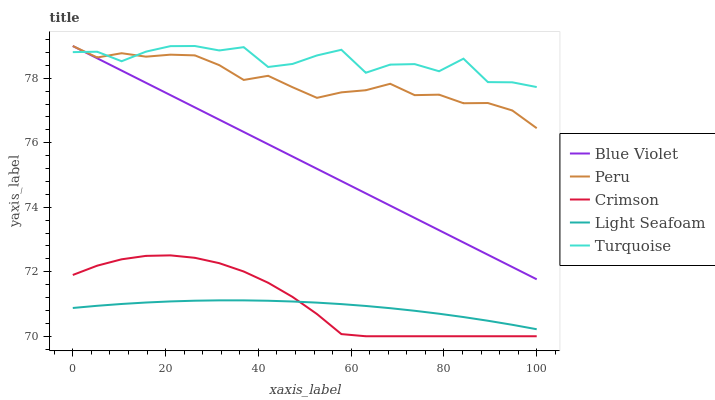Does Light Seafoam have the minimum area under the curve?
Answer yes or no. Yes. Does Turquoise have the maximum area under the curve?
Answer yes or no. Yes. Does Turquoise have the minimum area under the curve?
Answer yes or no. No. Does Light Seafoam have the maximum area under the curve?
Answer yes or no. No. Is Blue Violet the smoothest?
Answer yes or no. Yes. Is Turquoise the roughest?
Answer yes or no. Yes. Is Light Seafoam the smoothest?
Answer yes or no. No. Is Light Seafoam the roughest?
Answer yes or no. No. Does Crimson have the lowest value?
Answer yes or no. Yes. Does Light Seafoam have the lowest value?
Answer yes or no. No. Does Blue Violet have the highest value?
Answer yes or no. Yes. Does Light Seafoam have the highest value?
Answer yes or no. No. Is Crimson less than Blue Violet?
Answer yes or no. Yes. Is Blue Violet greater than Light Seafoam?
Answer yes or no. Yes. Does Peru intersect Blue Violet?
Answer yes or no. Yes. Is Peru less than Blue Violet?
Answer yes or no. No. Is Peru greater than Blue Violet?
Answer yes or no. No. Does Crimson intersect Blue Violet?
Answer yes or no. No. 